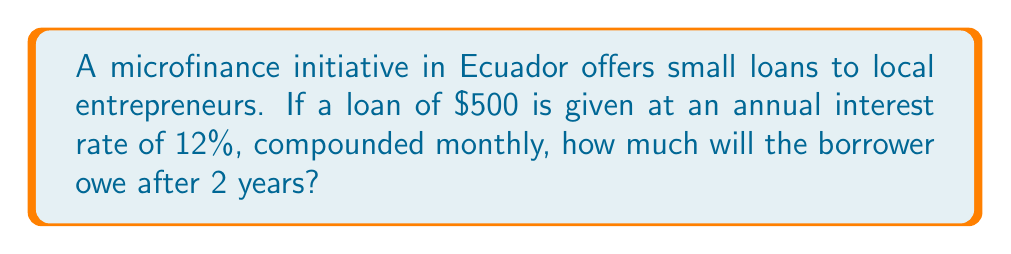Can you solve this math problem? To solve this problem, we'll use the compound interest formula:

$$ A = P(1 + \frac{r}{n})^{nt} $$

Where:
$A$ = final amount
$P$ = principal (initial loan amount)
$r$ = annual interest rate (as a decimal)
$n$ = number of times interest is compounded per year
$t$ = number of years

Given:
$P = 500$
$r = 0.12$ (12% expressed as a decimal)
$n = 12$ (compounded monthly)
$t = 2$ years

Let's substitute these values into the formula:

$$ A = 500(1 + \frac{0.12}{12})^{12 \cdot 2} $$

$$ A = 500(1 + 0.01)^{24} $$

$$ A = 500(1.01)^{24} $$

Using a calculator:

$$ A = 500 \cdot 1.2697 $$

$$ A = 634.85 $$

Therefore, after 2 years, the borrower will owe $634.85.
Answer: $634.85 